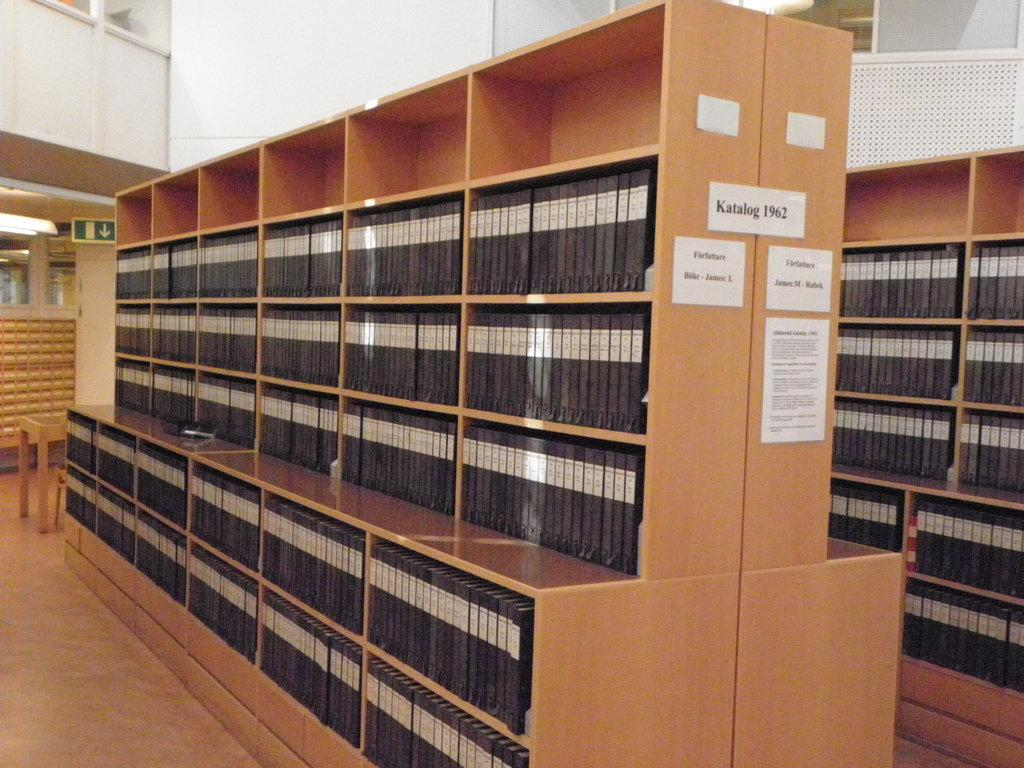What type of location is depicted in the image? The image shows an inner view of a building. What can be seen on the racks in the image? There are two racks with objects in the image, and the objects look like books. Are there any additional items on the racks? Yes, there are papers with text on one of the racks. Can you see a twig being used as a bookmark in any of the books in the image? There is no twig visible in the image, and no indication that any of the books have a twig used as a bookmark. 